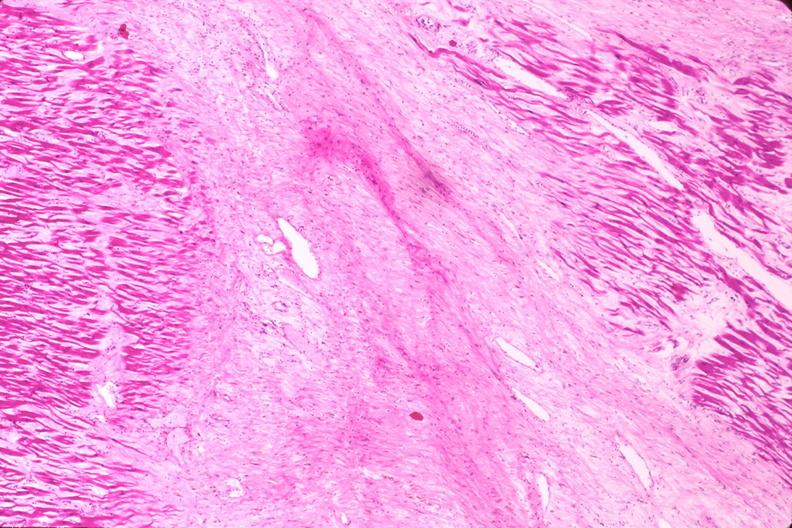what is present?
Answer the question using a single word or phrase. Cardiovascular 